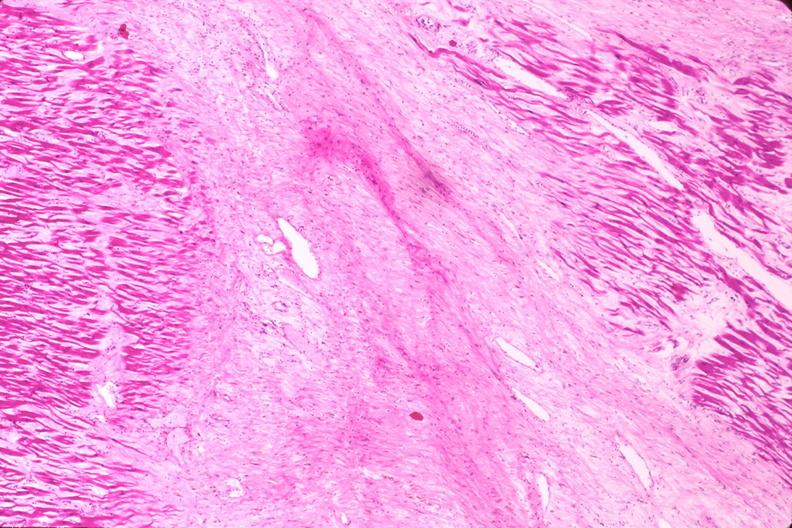what is present?
Answer the question using a single word or phrase. Cardiovascular 